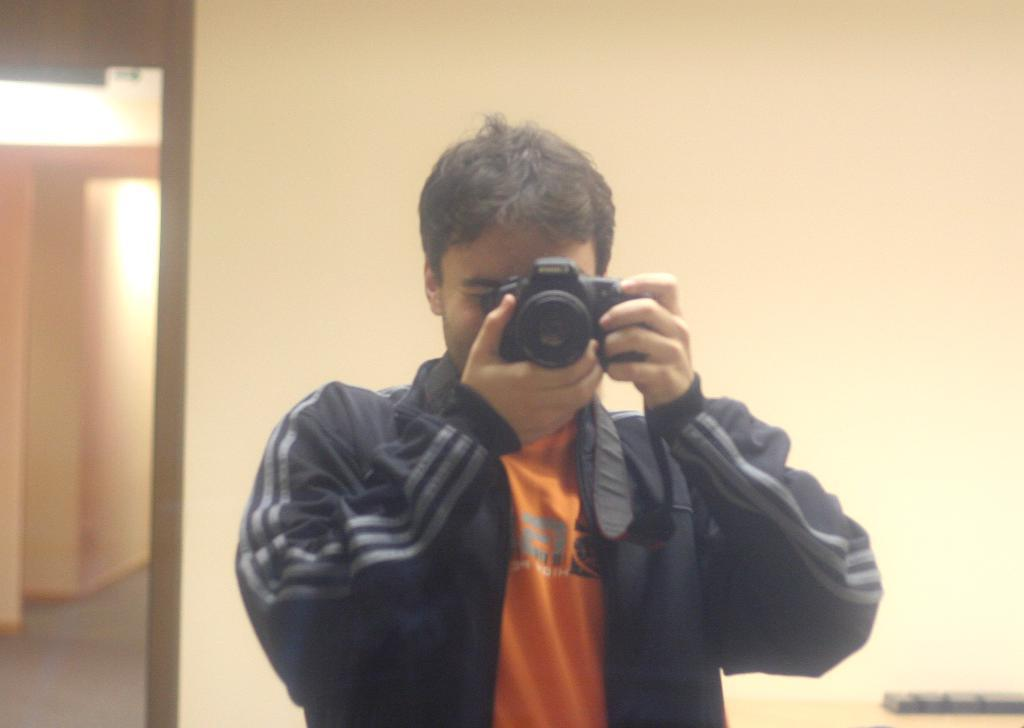What is the man in the image doing? The man is taking a picture with a camera. What can be seen in the background of the image? There is a door and a wall in the background of the image. Can you see any waves in the image? There are no waves present in the image. Is the man using a kettle to take the picture in the image? There is no kettle visible in the image, and the man is using a camera to take the picture. 